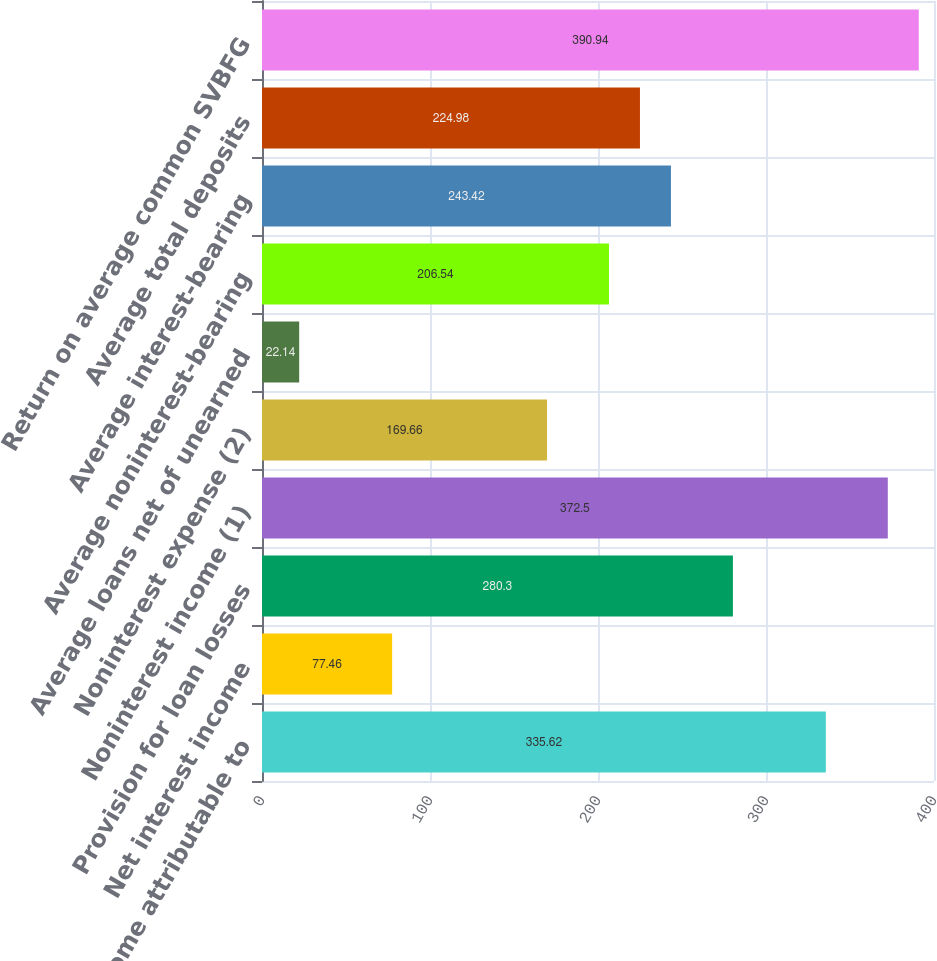Convert chart. <chart><loc_0><loc_0><loc_500><loc_500><bar_chart><fcel>Net income attributable to<fcel>Net interest income<fcel>Provision for loan losses<fcel>Noninterest income (1)<fcel>Noninterest expense (2)<fcel>Average loans net of unearned<fcel>Average noninterest-bearing<fcel>Average interest-bearing<fcel>Average total deposits<fcel>Return on average common SVBFG<nl><fcel>335.62<fcel>77.46<fcel>280.3<fcel>372.5<fcel>169.66<fcel>22.14<fcel>206.54<fcel>243.42<fcel>224.98<fcel>390.94<nl></chart> 